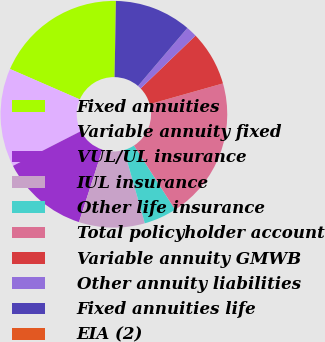<chart> <loc_0><loc_0><loc_500><loc_500><pie_chart><fcel>Fixed annuities<fcel>Variable annuity fixed<fcel>VUL/UL insurance<fcel>IUL insurance<fcel>Other life insurance<fcel>Total policyholder account<fcel>Variable annuity GMWB<fcel>Other annuity liabilities<fcel>Fixed annuities life<fcel>EIA (2)<nl><fcel>18.74%<fcel>14.06%<fcel>12.5%<fcel>9.38%<fcel>4.69%<fcel>20.3%<fcel>7.82%<fcel>1.57%<fcel>10.94%<fcel>0.01%<nl></chart> 